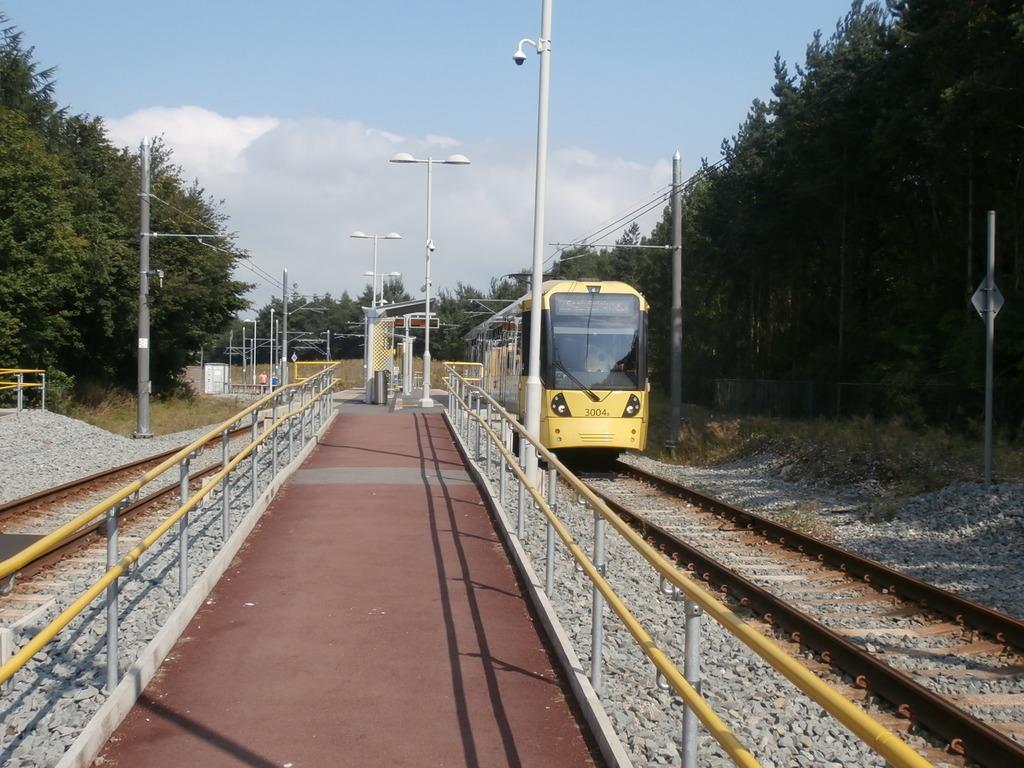Please provide a concise description of this image. In the image in the center, we can see one train, which is in yellow color. And we can see the fences, railway tracks and stones. In the background we can see the sky, clouds, trees, poles, sign boards etc. 